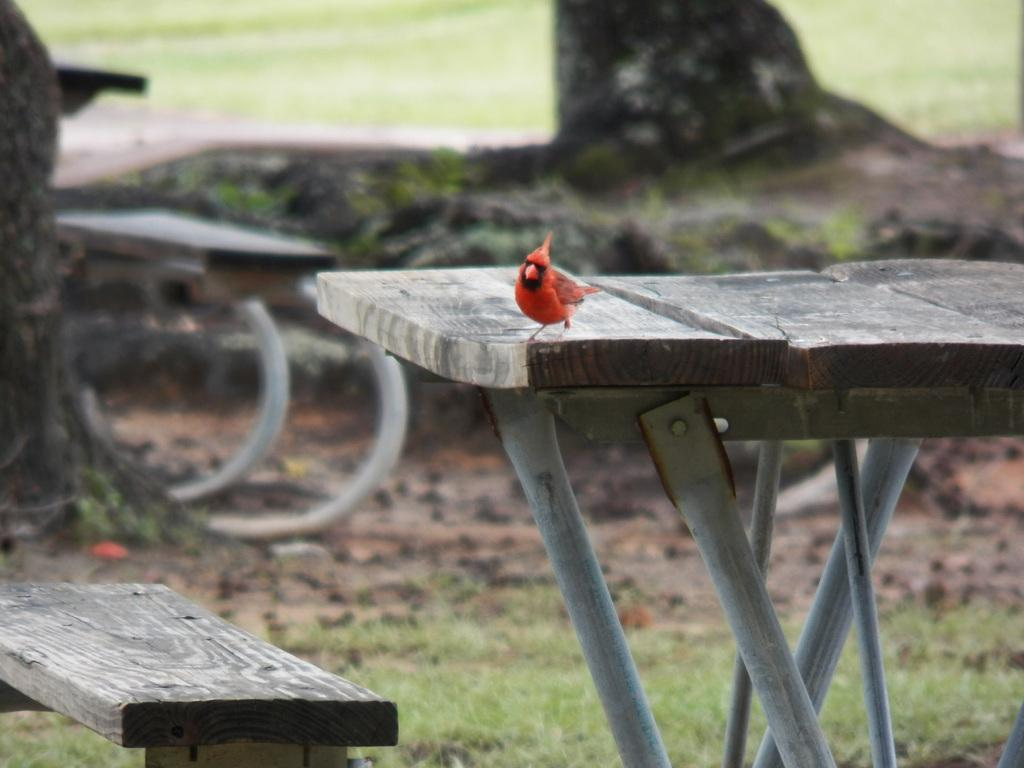What type of animal is present in the image? There is a bird in the image. Where is the bird located? The bird is on a wooden table. What type of advertisement can be seen on the bird's back in the image? There is no advertisement present on the bird's back in the image. Is there a train visible in the image? There is no train present in the image; it only features a bird on a wooden table. 